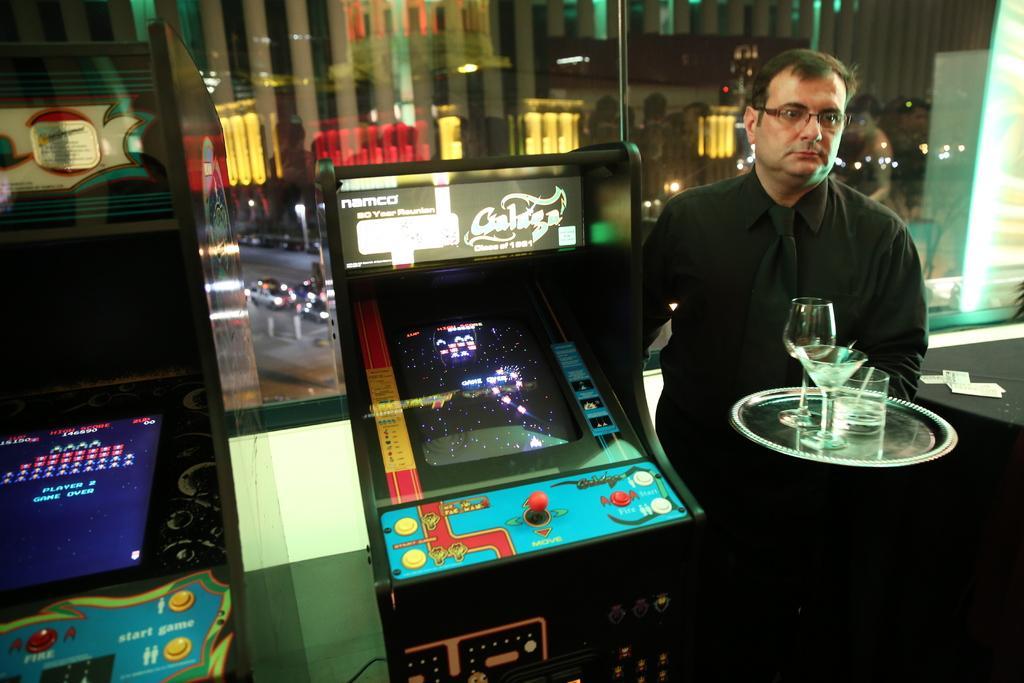Can you describe this image briefly? The man on the right side is standing and he is holding the plate containing glasses in his hands. Beside him, we see a table on which small papers are placed. Beside him, we see the games. In the background, we see a glass window from which we can see buildings and the cars moving on the road. 